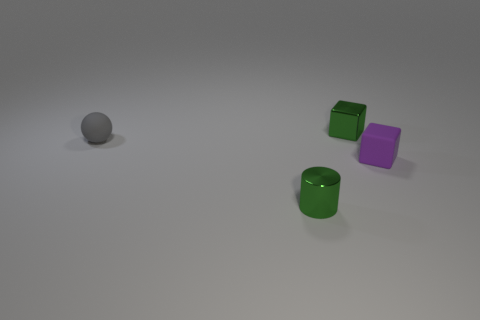Do the small metal cube and the small metal cylinder have the same color?
Your answer should be compact. Yes. Are there any other small yellow cylinders that have the same material as the tiny cylinder?
Keep it short and to the point. No. How many objects are either things behind the tiny rubber ball or metal objects?
Your answer should be very brief. 2. Are any small purple rubber cubes visible?
Your response must be concise. Yes. The small thing that is in front of the green metal block and behind the rubber block has what shape?
Your answer should be very brief. Sphere. Do the small metallic object behind the shiny cylinder and the metal cylinder have the same color?
Your answer should be compact. Yes. What number of other metal things are the same shape as the tiny purple thing?
Provide a succinct answer. 1. What number of things are either small things that are in front of the tiny gray rubber ball or tiny cubes that are to the right of the tiny green metal cube?
Make the answer very short. 2. How many red objects are tiny matte blocks or small shiny objects?
Your answer should be very brief. 0. There is a tiny thing that is left of the small purple cube and on the right side of the tiny cylinder; what material is it made of?
Make the answer very short. Metal. 